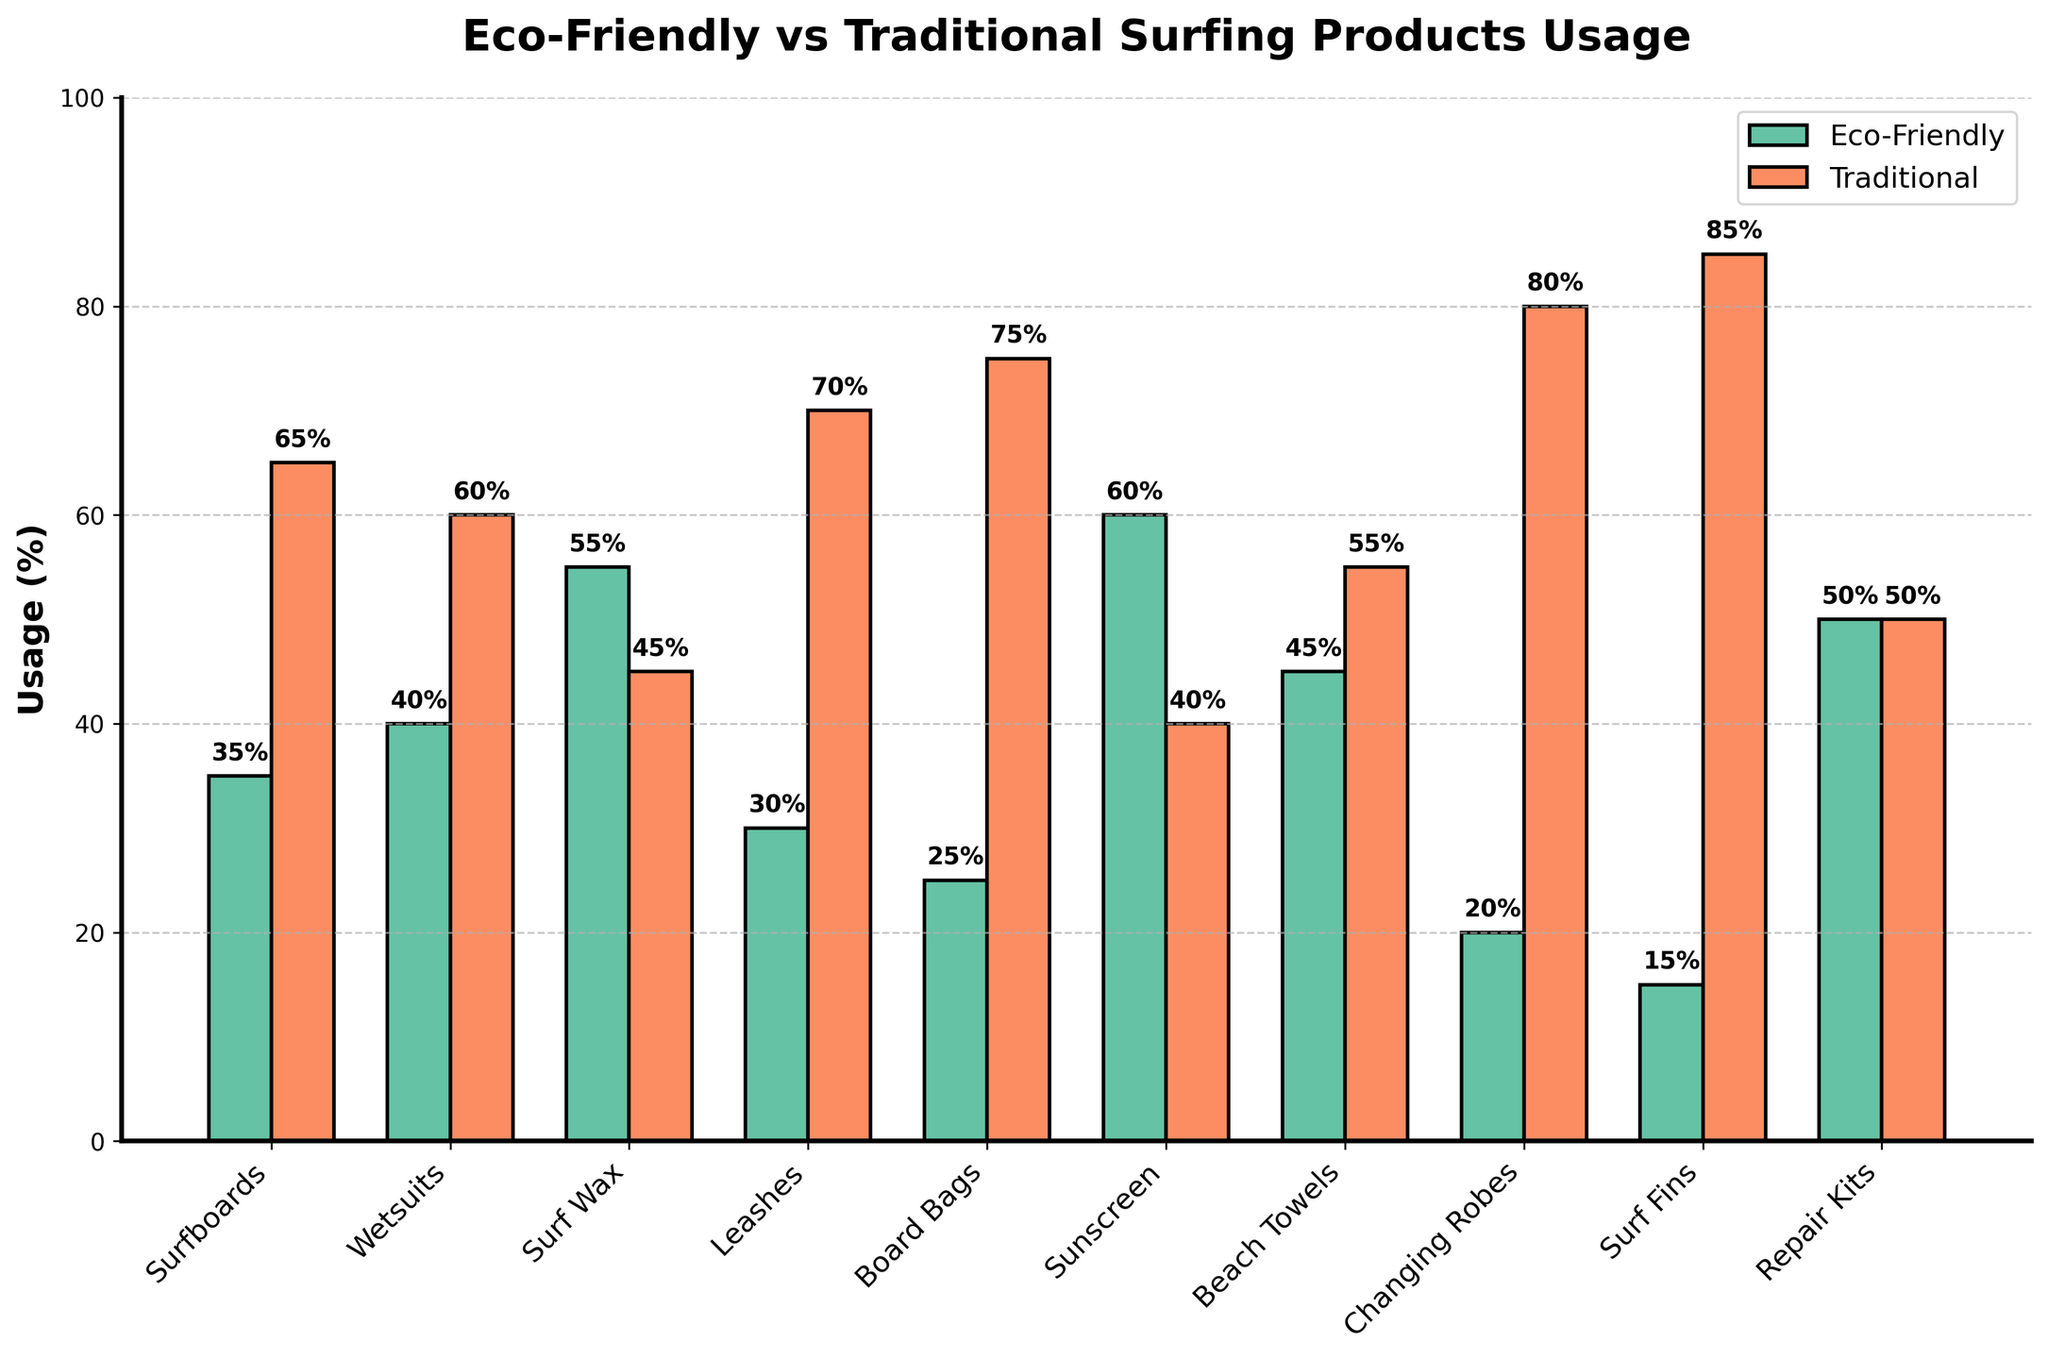What's the product with the highest eco-friendly usage percentage? The eco-friendly usage percentage is highest for Sunscreen, as shown by the tallest green bar labeled with 60%.
Answer: Sunscreen Which product type has the largest difference in usage percentage between eco-friendly and traditional products? The largest difference occurs where the eco-friendly and traditional usage percentages are farthest apart. In this case, it's Surf Fins (15% eco-friendly, 85% traditional) with a difference of 70%.
Answer: Surf Fins What is the average eco-friendly usage percentage for Surfboards, Wetsuits, and Surf Wax? The eco-friendly usage percentages are: Surfboards 35%, Wetsuits 40%, Surf Wax 55%. Sum these values to get 130%, then divide by 3 to find the average: 130 / 3 = 43.33%.
Answer: 43.33% Which product type has an equal usage percentage between eco-friendly and traditional products? The product with equal usage percentages for both eco-friendly and traditional products is Repair Kits, each at 50%.
Answer: Repair Kits Among Surfboards, Wetsuits, and Leashes, which product has the lowest eco-friendly usage percentage? Compare the eco-friendly usage percentages of Surfboards (35%), Wetsuits (40%), and Leashes (30%). Leashes have the lowest percentage at 30%.
Answer: Leashes Which product has a higher eco-friendly usage, Beach Towels or Board Bags? By comparing the eco-friendly usage percentages, Beach Towels have 45%, whereas Board Bags have 25%. Thus, Beach Towels have higher eco-friendly usage.
Answer: Beach Towels How much higher is the eco-friendly usage percentage for Sunscreen compared to Surf Fins? Calculate the difference between Sunscreen (60%) and Surf Fins (15%): 60 - 15 = 45%.
Answer: 45% What's the total eco-friendly usage percentage for Changing Robes and Surf Fins combined? Adding the eco-friendly usage percentages of Changing Robes (20%) and Surf Fins (15%) results in: 20 + 15 = 35%.
Answer: 35% Is the traditional usage percentage more than 75% for any products? Reviewing the traditional usage percentages, it exceeds 75% for Board Bags (75%) and Changing Robes (80%). Thus, it's more than 75% for Changing Robes.
Answer: Yes What is the combined traditional usage percentage for Surfboards and Leashes? Sum the traditional usage percentages of Surfboards (65%) and Leashes (70%): 65 + 70 = 135%.
Answer: 135% 